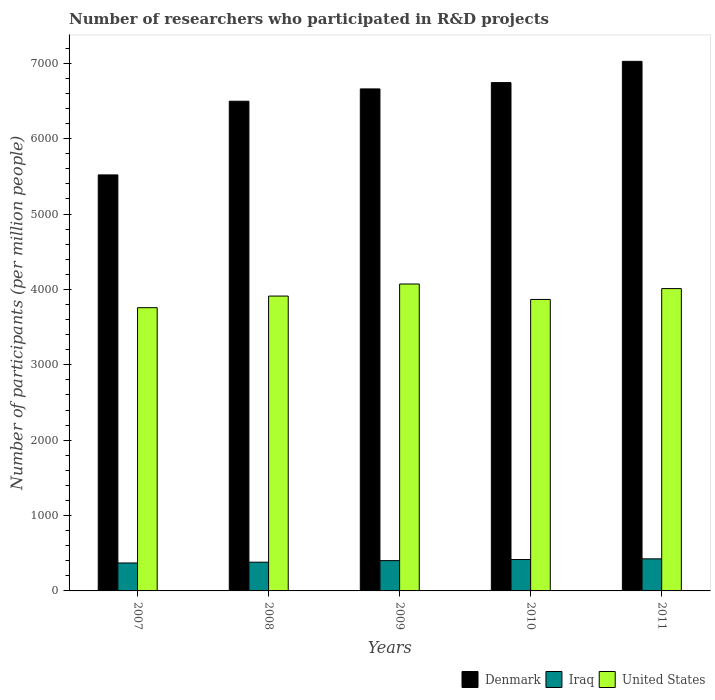How many groups of bars are there?
Keep it short and to the point. 5. Are the number of bars per tick equal to the number of legend labels?
Provide a short and direct response. Yes. How many bars are there on the 4th tick from the right?
Make the answer very short. 3. What is the label of the 3rd group of bars from the left?
Your answer should be very brief. 2009. In how many cases, is the number of bars for a given year not equal to the number of legend labels?
Make the answer very short. 0. What is the number of researchers who participated in R&D projects in Iraq in 2010?
Offer a very short reply. 416.25. Across all years, what is the maximum number of researchers who participated in R&D projects in Denmark?
Your answer should be very brief. 7025.82. Across all years, what is the minimum number of researchers who participated in R&D projects in Iraq?
Your response must be concise. 370.71. In which year was the number of researchers who participated in R&D projects in United States maximum?
Give a very brief answer. 2009. In which year was the number of researchers who participated in R&D projects in Denmark minimum?
Offer a very short reply. 2007. What is the total number of researchers who participated in R&D projects in United States in the graph?
Your response must be concise. 1.96e+04. What is the difference between the number of researchers who participated in R&D projects in Denmark in 2008 and that in 2009?
Your answer should be compact. -163.38. What is the difference between the number of researchers who participated in R&D projects in Denmark in 2011 and the number of researchers who participated in R&D projects in United States in 2007?
Give a very brief answer. 3268.03. What is the average number of researchers who participated in R&D projects in Denmark per year?
Give a very brief answer. 6489.19. In the year 2008, what is the difference between the number of researchers who participated in R&D projects in Denmark and number of researchers who participated in R&D projects in Iraq?
Provide a short and direct response. 6115.74. In how many years, is the number of researchers who participated in R&D projects in United States greater than 6400?
Your answer should be very brief. 0. What is the ratio of the number of researchers who participated in R&D projects in United States in 2007 to that in 2008?
Ensure brevity in your answer.  0.96. Is the number of researchers who participated in R&D projects in United States in 2009 less than that in 2011?
Offer a terse response. No. What is the difference between the highest and the second highest number of researchers who participated in R&D projects in Denmark?
Give a very brief answer. 281.92. What is the difference between the highest and the lowest number of researchers who participated in R&D projects in Iraq?
Your response must be concise. 54.76. What does the 1st bar from the right in 2010 represents?
Offer a very short reply. United States. How many bars are there?
Provide a short and direct response. 15. Are all the bars in the graph horizontal?
Provide a succinct answer. No. What is the difference between two consecutive major ticks on the Y-axis?
Make the answer very short. 1000. How are the legend labels stacked?
Make the answer very short. Horizontal. What is the title of the graph?
Keep it short and to the point. Number of researchers who participated in R&D projects. What is the label or title of the Y-axis?
Your answer should be compact. Number of participants (per million people). What is the Number of participants (per million people) in Denmark in 2007?
Your answer should be very brief. 5519.32. What is the Number of participants (per million people) of Iraq in 2007?
Keep it short and to the point. 370.71. What is the Number of participants (per million people) of United States in 2007?
Ensure brevity in your answer.  3757.78. What is the Number of participants (per million people) of Denmark in 2008?
Provide a short and direct response. 6496.76. What is the Number of participants (per million people) in Iraq in 2008?
Provide a succinct answer. 381.03. What is the Number of participants (per million people) in United States in 2008?
Provide a short and direct response. 3911.75. What is the Number of participants (per million people) of Denmark in 2009?
Offer a very short reply. 6660.14. What is the Number of participants (per million people) of Iraq in 2009?
Offer a very short reply. 401.99. What is the Number of participants (per million people) in United States in 2009?
Provide a short and direct response. 4071.79. What is the Number of participants (per million people) in Denmark in 2010?
Provide a succinct answer. 6743.9. What is the Number of participants (per million people) of Iraq in 2010?
Offer a very short reply. 416.25. What is the Number of participants (per million people) of United States in 2010?
Offer a very short reply. 3866.96. What is the Number of participants (per million people) of Denmark in 2011?
Offer a terse response. 7025.82. What is the Number of participants (per million people) of Iraq in 2011?
Your answer should be very brief. 425.48. What is the Number of participants (per million people) of United States in 2011?
Offer a very short reply. 4010.84. Across all years, what is the maximum Number of participants (per million people) of Denmark?
Ensure brevity in your answer.  7025.82. Across all years, what is the maximum Number of participants (per million people) of Iraq?
Provide a short and direct response. 425.48. Across all years, what is the maximum Number of participants (per million people) in United States?
Your answer should be compact. 4071.79. Across all years, what is the minimum Number of participants (per million people) of Denmark?
Provide a succinct answer. 5519.32. Across all years, what is the minimum Number of participants (per million people) of Iraq?
Your answer should be compact. 370.71. Across all years, what is the minimum Number of participants (per million people) of United States?
Offer a terse response. 3757.78. What is the total Number of participants (per million people) in Denmark in the graph?
Your answer should be compact. 3.24e+04. What is the total Number of participants (per million people) of Iraq in the graph?
Provide a succinct answer. 1995.47. What is the total Number of participants (per million people) in United States in the graph?
Give a very brief answer. 1.96e+04. What is the difference between the Number of participants (per million people) in Denmark in 2007 and that in 2008?
Your response must be concise. -977.45. What is the difference between the Number of participants (per million people) of Iraq in 2007 and that in 2008?
Your answer should be very brief. -10.31. What is the difference between the Number of participants (per million people) in United States in 2007 and that in 2008?
Offer a very short reply. -153.97. What is the difference between the Number of participants (per million people) in Denmark in 2007 and that in 2009?
Offer a terse response. -1140.83. What is the difference between the Number of participants (per million people) of Iraq in 2007 and that in 2009?
Provide a short and direct response. -31.28. What is the difference between the Number of participants (per million people) in United States in 2007 and that in 2009?
Your response must be concise. -314.01. What is the difference between the Number of participants (per million people) in Denmark in 2007 and that in 2010?
Make the answer very short. -1224.58. What is the difference between the Number of participants (per million people) of Iraq in 2007 and that in 2010?
Make the answer very short. -45.54. What is the difference between the Number of participants (per million people) in United States in 2007 and that in 2010?
Offer a very short reply. -109.18. What is the difference between the Number of participants (per million people) of Denmark in 2007 and that in 2011?
Your answer should be compact. -1506.5. What is the difference between the Number of participants (per million people) in Iraq in 2007 and that in 2011?
Provide a short and direct response. -54.76. What is the difference between the Number of participants (per million people) of United States in 2007 and that in 2011?
Offer a very short reply. -253.06. What is the difference between the Number of participants (per million people) in Denmark in 2008 and that in 2009?
Your answer should be very brief. -163.38. What is the difference between the Number of participants (per million people) in Iraq in 2008 and that in 2009?
Ensure brevity in your answer.  -20.97. What is the difference between the Number of participants (per million people) of United States in 2008 and that in 2009?
Offer a terse response. -160.03. What is the difference between the Number of participants (per million people) of Denmark in 2008 and that in 2010?
Your answer should be very brief. -247.13. What is the difference between the Number of participants (per million people) of Iraq in 2008 and that in 2010?
Offer a terse response. -35.23. What is the difference between the Number of participants (per million people) of United States in 2008 and that in 2010?
Ensure brevity in your answer.  44.79. What is the difference between the Number of participants (per million people) of Denmark in 2008 and that in 2011?
Your answer should be compact. -529.05. What is the difference between the Number of participants (per million people) in Iraq in 2008 and that in 2011?
Make the answer very short. -44.45. What is the difference between the Number of participants (per million people) in United States in 2008 and that in 2011?
Give a very brief answer. -99.09. What is the difference between the Number of participants (per million people) of Denmark in 2009 and that in 2010?
Offer a very short reply. -83.75. What is the difference between the Number of participants (per million people) of Iraq in 2009 and that in 2010?
Provide a succinct answer. -14.26. What is the difference between the Number of participants (per million people) of United States in 2009 and that in 2010?
Provide a short and direct response. 204.83. What is the difference between the Number of participants (per million people) in Denmark in 2009 and that in 2011?
Ensure brevity in your answer.  -365.67. What is the difference between the Number of participants (per million people) of Iraq in 2009 and that in 2011?
Your response must be concise. -23.48. What is the difference between the Number of participants (per million people) in United States in 2009 and that in 2011?
Give a very brief answer. 60.95. What is the difference between the Number of participants (per million people) of Denmark in 2010 and that in 2011?
Offer a terse response. -281.92. What is the difference between the Number of participants (per million people) of Iraq in 2010 and that in 2011?
Your answer should be compact. -9.22. What is the difference between the Number of participants (per million people) in United States in 2010 and that in 2011?
Ensure brevity in your answer.  -143.88. What is the difference between the Number of participants (per million people) in Denmark in 2007 and the Number of participants (per million people) in Iraq in 2008?
Your answer should be very brief. 5138.29. What is the difference between the Number of participants (per million people) of Denmark in 2007 and the Number of participants (per million people) of United States in 2008?
Make the answer very short. 1607.56. What is the difference between the Number of participants (per million people) of Iraq in 2007 and the Number of participants (per million people) of United States in 2008?
Provide a succinct answer. -3541.04. What is the difference between the Number of participants (per million people) in Denmark in 2007 and the Number of participants (per million people) in Iraq in 2009?
Provide a succinct answer. 5117.32. What is the difference between the Number of participants (per million people) of Denmark in 2007 and the Number of participants (per million people) of United States in 2009?
Ensure brevity in your answer.  1447.53. What is the difference between the Number of participants (per million people) of Iraq in 2007 and the Number of participants (per million people) of United States in 2009?
Your answer should be very brief. -3701.07. What is the difference between the Number of participants (per million people) in Denmark in 2007 and the Number of participants (per million people) in Iraq in 2010?
Ensure brevity in your answer.  5103.06. What is the difference between the Number of participants (per million people) of Denmark in 2007 and the Number of participants (per million people) of United States in 2010?
Keep it short and to the point. 1652.35. What is the difference between the Number of participants (per million people) of Iraq in 2007 and the Number of participants (per million people) of United States in 2010?
Offer a very short reply. -3496.25. What is the difference between the Number of participants (per million people) in Denmark in 2007 and the Number of participants (per million people) in Iraq in 2011?
Your response must be concise. 5093.84. What is the difference between the Number of participants (per million people) of Denmark in 2007 and the Number of participants (per million people) of United States in 2011?
Make the answer very short. 1508.47. What is the difference between the Number of participants (per million people) of Iraq in 2007 and the Number of participants (per million people) of United States in 2011?
Give a very brief answer. -3640.13. What is the difference between the Number of participants (per million people) of Denmark in 2008 and the Number of participants (per million people) of Iraq in 2009?
Keep it short and to the point. 6094.77. What is the difference between the Number of participants (per million people) of Denmark in 2008 and the Number of participants (per million people) of United States in 2009?
Ensure brevity in your answer.  2424.97. What is the difference between the Number of participants (per million people) of Iraq in 2008 and the Number of participants (per million people) of United States in 2009?
Provide a succinct answer. -3690.76. What is the difference between the Number of participants (per million people) in Denmark in 2008 and the Number of participants (per million people) in Iraq in 2010?
Ensure brevity in your answer.  6080.51. What is the difference between the Number of participants (per million people) in Denmark in 2008 and the Number of participants (per million people) in United States in 2010?
Give a very brief answer. 2629.8. What is the difference between the Number of participants (per million people) in Iraq in 2008 and the Number of participants (per million people) in United States in 2010?
Keep it short and to the point. -3485.94. What is the difference between the Number of participants (per million people) of Denmark in 2008 and the Number of participants (per million people) of Iraq in 2011?
Keep it short and to the point. 6071.29. What is the difference between the Number of participants (per million people) of Denmark in 2008 and the Number of participants (per million people) of United States in 2011?
Your answer should be very brief. 2485.92. What is the difference between the Number of participants (per million people) of Iraq in 2008 and the Number of participants (per million people) of United States in 2011?
Offer a very short reply. -3629.82. What is the difference between the Number of participants (per million people) in Denmark in 2009 and the Number of participants (per million people) in Iraq in 2010?
Offer a very short reply. 6243.89. What is the difference between the Number of participants (per million people) of Denmark in 2009 and the Number of participants (per million people) of United States in 2010?
Make the answer very short. 2793.18. What is the difference between the Number of participants (per million people) of Iraq in 2009 and the Number of participants (per million people) of United States in 2010?
Ensure brevity in your answer.  -3464.97. What is the difference between the Number of participants (per million people) in Denmark in 2009 and the Number of participants (per million people) in Iraq in 2011?
Give a very brief answer. 6234.67. What is the difference between the Number of participants (per million people) in Denmark in 2009 and the Number of participants (per million people) in United States in 2011?
Keep it short and to the point. 2649.3. What is the difference between the Number of participants (per million people) in Iraq in 2009 and the Number of participants (per million people) in United States in 2011?
Your answer should be very brief. -3608.85. What is the difference between the Number of participants (per million people) in Denmark in 2010 and the Number of participants (per million people) in Iraq in 2011?
Offer a very short reply. 6318.42. What is the difference between the Number of participants (per million people) in Denmark in 2010 and the Number of participants (per million people) in United States in 2011?
Ensure brevity in your answer.  2733.06. What is the difference between the Number of participants (per million people) of Iraq in 2010 and the Number of participants (per million people) of United States in 2011?
Provide a short and direct response. -3594.59. What is the average Number of participants (per million people) in Denmark per year?
Keep it short and to the point. 6489.19. What is the average Number of participants (per million people) in Iraq per year?
Provide a succinct answer. 399.09. What is the average Number of participants (per million people) of United States per year?
Offer a very short reply. 3923.83. In the year 2007, what is the difference between the Number of participants (per million people) in Denmark and Number of participants (per million people) in Iraq?
Keep it short and to the point. 5148.6. In the year 2007, what is the difference between the Number of participants (per million people) of Denmark and Number of participants (per million people) of United States?
Your answer should be compact. 1761.53. In the year 2007, what is the difference between the Number of participants (per million people) of Iraq and Number of participants (per million people) of United States?
Your response must be concise. -3387.07. In the year 2008, what is the difference between the Number of participants (per million people) of Denmark and Number of participants (per million people) of Iraq?
Give a very brief answer. 6115.74. In the year 2008, what is the difference between the Number of participants (per million people) in Denmark and Number of participants (per million people) in United States?
Keep it short and to the point. 2585.01. In the year 2008, what is the difference between the Number of participants (per million people) of Iraq and Number of participants (per million people) of United States?
Your answer should be compact. -3530.73. In the year 2009, what is the difference between the Number of participants (per million people) in Denmark and Number of participants (per million people) in Iraq?
Provide a succinct answer. 6258.15. In the year 2009, what is the difference between the Number of participants (per million people) of Denmark and Number of participants (per million people) of United States?
Give a very brief answer. 2588.35. In the year 2009, what is the difference between the Number of participants (per million people) in Iraq and Number of participants (per million people) in United States?
Make the answer very short. -3669.8. In the year 2010, what is the difference between the Number of participants (per million people) in Denmark and Number of participants (per million people) in Iraq?
Your answer should be very brief. 6327.64. In the year 2010, what is the difference between the Number of participants (per million people) in Denmark and Number of participants (per million people) in United States?
Offer a terse response. 2876.93. In the year 2010, what is the difference between the Number of participants (per million people) in Iraq and Number of participants (per million people) in United States?
Give a very brief answer. -3450.71. In the year 2011, what is the difference between the Number of participants (per million people) in Denmark and Number of participants (per million people) in Iraq?
Make the answer very short. 6600.34. In the year 2011, what is the difference between the Number of participants (per million people) in Denmark and Number of participants (per million people) in United States?
Provide a succinct answer. 3014.97. In the year 2011, what is the difference between the Number of participants (per million people) in Iraq and Number of participants (per million people) in United States?
Provide a short and direct response. -3585.36. What is the ratio of the Number of participants (per million people) of Denmark in 2007 to that in 2008?
Provide a short and direct response. 0.85. What is the ratio of the Number of participants (per million people) of Iraq in 2007 to that in 2008?
Give a very brief answer. 0.97. What is the ratio of the Number of participants (per million people) of United States in 2007 to that in 2008?
Provide a short and direct response. 0.96. What is the ratio of the Number of participants (per million people) of Denmark in 2007 to that in 2009?
Your answer should be compact. 0.83. What is the ratio of the Number of participants (per million people) in Iraq in 2007 to that in 2009?
Your answer should be very brief. 0.92. What is the ratio of the Number of participants (per million people) in United States in 2007 to that in 2009?
Your response must be concise. 0.92. What is the ratio of the Number of participants (per million people) in Denmark in 2007 to that in 2010?
Offer a very short reply. 0.82. What is the ratio of the Number of participants (per million people) of Iraq in 2007 to that in 2010?
Your answer should be compact. 0.89. What is the ratio of the Number of participants (per million people) of United States in 2007 to that in 2010?
Make the answer very short. 0.97. What is the ratio of the Number of participants (per million people) in Denmark in 2007 to that in 2011?
Your response must be concise. 0.79. What is the ratio of the Number of participants (per million people) of Iraq in 2007 to that in 2011?
Keep it short and to the point. 0.87. What is the ratio of the Number of participants (per million people) in United States in 2007 to that in 2011?
Offer a terse response. 0.94. What is the ratio of the Number of participants (per million people) of Denmark in 2008 to that in 2009?
Give a very brief answer. 0.98. What is the ratio of the Number of participants (per million people) in Iraq in 2008 to that in 2009?
Provide a short and direct response. 0.95. What is the ratio of the Number of participants (per million people) of United States in 2008 to that in 2009?
Provide a succinct answer. 0.96. What is the ratio of the Number of participants (per million people) in Denmark in 2008 to that in 2010?
Ensure brevity in your answer.  0.96. What is the ratio of the Number of participants (per million people) of Iraq in 2008 to that in 2010?
Your answer should be very brief. 0.92. What is the ratio of the Number of participants (per million people) of United States in 2008 to that in 2010?
Provide a short and direct response. 1.01. What is the ratio of the Number of participants (per million people) in Denmark in 2008 to that in 2011?
Provide a short and direct response. 0.92. What is the ratio of the Number of participants (per million people) of Iraq in 2008 to that in 2011?
Keep it short and to the point. 0.9. What is the ratio of the Number of participants (per million people) of United States in 2008 to that in 2011?
Your answer should be very brief. 0.98. What is the ratio of the Number of participants (per million people) of Denmark in 2009 to that in 2010?
Offer a very short reply. 0.99. What is the ratio of the Number of participants (per million people) of Iraq in 2009 to that in 2010?
Make the answer very short. 0.97. What is the ratio of the Number of participants (per million people) in United States in 2009 to that in 2010?
Your response must be concise. 1.05. What is the ratio of the Number of participants (per million people) in Denmark in 2009 to that in 2011?
Make the answer very short. 0.95. What is the ratio of the Number of participants (per million people) in Iraq in 2009 to that in 2011?
Offer a terse response. 0.94. What is the ratio of the Number of participants (per million people) of United States in 2009 to that in 2011?
Offer a terse response. 1.02. What is the ratio of the Number of participants (per million people) in Denmark in 2010 to that in 2011?
Make the answer very short. 0.96. What is the ratio of the Number of participants (per million people) of Iraq in 2010 to that in 2011?
Your answer should be compact. 0.98. What is the ratio of the Number of participants (per million people) of United States in 2010 to that in 2011?
Offer a very short reply. 0.96. What is the difference between the highest and the second highest Number of participants (per million people) of Denmark?
Keep it short and to the point. 281.92. What is the difference between the highest and the second highest Number of participants (per million people) in Iraq?
Provide a succinct answer. 9.22. What is the difference between the highest and the second highest Number of participants (per million people) in United States?
Your response must be concise. 60.95. What is the difference between the highest and the lowest Number of participants (per million people) in Denmark?
Provide a succinct answer. 1506.5. What is the difference between the highest and the lowest Number of participants (per million people) in Iraq?
Provide a short and direct response. 54.76. What is the difference between the highest and the lowest Number of participants (per million people) in United States?
Your response must be concise. 314.01. 